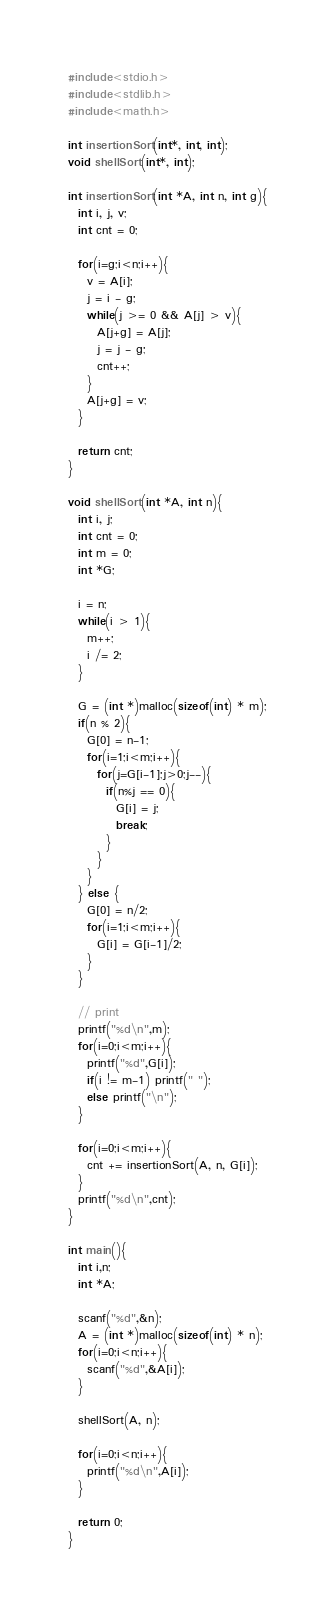Convert code to text. <code><loc_0><loc_0><loc_500><loc_500><_C_>#include<stdio.h>
#include<stdlib.h>
#include<math.h>

int insertionSort(int*, int, int);
void shellSort(int*, int);

int insertionSort(int *A, int n, int g){
  int i, j, v;
  int cnt = 0;

  for(i=g;i<n;i++){
    v = A[i];
    j = i - g;
    while(j >= 0 && A[j] > v){
      A[j+g] = A[j];
      j = j - g;
      cnt++;
    }
    A[j+g] = v;
  }

  return cnt;
}

void shellSort(int *A, int n){
  int i, j;
  int cnt = 0;
  int m = 0;
  int *G;

  i = n;
  while(i > 1){
    m++;
    i /= 2;
  }

  G = (int *)malloc(sizeof(int) * m);
  if(n % 2){
    G[0] = n-1;
    for(i=1;i<m;i++){
      for(j=G[i-1];j>0;j--){
        if(n%j == 0){
          G[i] = j;
          break;
        }
      }
    }
  } else {
    G[0] = n/2;
    for(i=1;i<m;i++){
      G[i] = G[i-1]/2;
    }
  }

  // print
  printf("%d\n",m);
  for(i=0;i<m;i++){
    printf("%d",G[i]);
    if(i != m-1) printf(" ");
    else printf("\n");
  }

  for(i=0;i<m;i++){
    cnt += insertionSort(A, n, G[i]);
  }
  printf("%d\n",cnt);
}

int main(){
  int i,n;
  int *A;

  scanf("%d",&n);
  A = (int *)malloc(sizeof(int) * n);
  for(i=0;i<n;i++){
    scanf("%d",&A[i]);
  }

  shellSort(A, n);

  for(i=0;i<n;i++){
    printf("%d\n",A[i]);
  }

  return 0;
}

</code> 